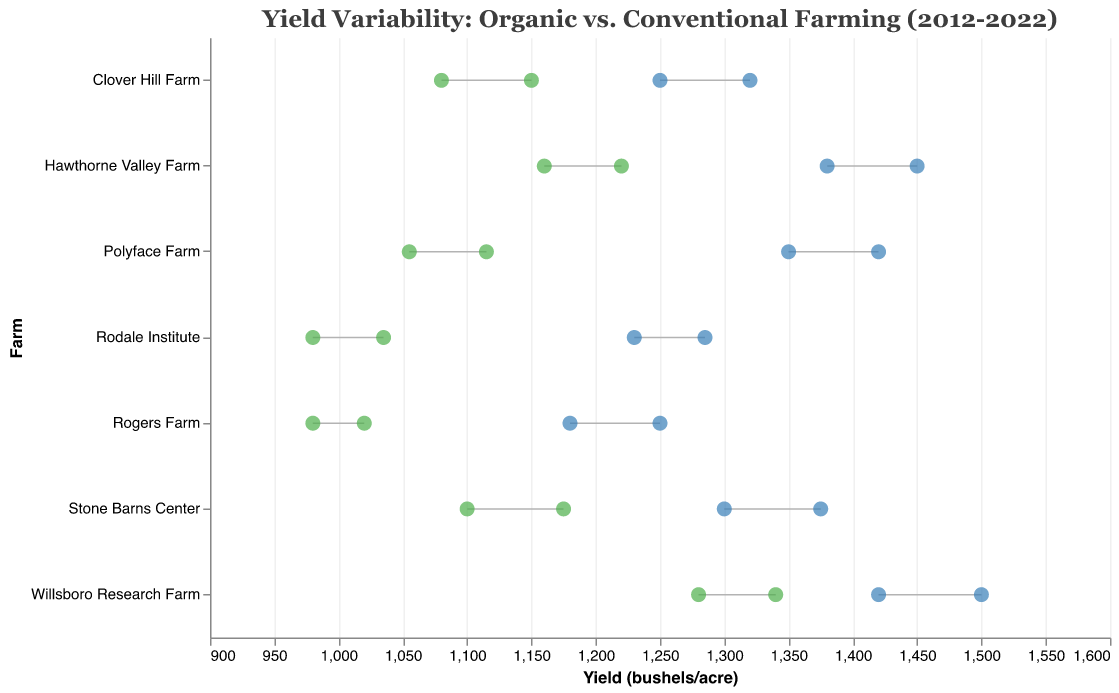what is the title of the plotted figure? The title of the plotted figure is usually positioned at the top center of the chart and provides a summary of what the chart is about. Here, it reads: "Yield Variability: Organic vs. Conventional Farming (2012-2022)."
Answer: Yield Variability: Organic vs. Conventional Farming (2012-2022) What does the color green represent in the figure? In the figure, the color green is used to represent the yield data for organic farming in both 2012 and 2022. The green circles mark the yield values at these two points in time.
Answer: Organic farming Which farm had the highest yield in 2022 under conventional farming methods? To find this, look for the blue circle farthest to the right for the year 2022. That corresponds to the highest yield value in 2022 under conventional farming methods. It is from "Cornell University Ag Extension" with a yield of 1500 bushels/acre.
Answer: Cornell University Ag Extension Which farms increased their yield from 2012 to 2022 under organic farming methods? To answer this, examine the green circles for each farm. If the circle for 2022 is farther to the right than the circle for 2012, the yield increased. "Willsboro Research Farm," "Rogers Farm," "Stone Barns Center," "Polyface Farm," "Rodale Institute," "Hawthorne Valley Farm," and "Clover Hill Farm" all show increased yields.
Answer: Willsboro Research Farm, Rogers Farm, Stone Barns Center, Polyface Farm, Rodale Institute, Hawthorne Valley Farm, Clover Hill Farm What is the average yield in 2022 for organic farming across all farms? Add the 2022 yield values for organic farming for all farms: 1340, 1020, 1175, 1115, 1035, 1220, and 1150, then divide by the number of farms (7). The sum is 8155, and the average yield is 8155 / 7 = 1165 bushels/acre.
Answer: 1165 bushels/acre By how much did the yield increase for "Rodale Institute" from 2012 to 2022 under organic farming methods? Subtract the 2012 yield from the 2022 yield for "Rodale Institute." The yields are 1035 (2022) and 980 (2012). The yield increase is 1035 - 980 = 55 bushels/acre.
Answer: 55 bushels/acre Is there any farm where the yield decreased from 2012 to 2022 under either farming method? Look at the relative positions of the circles for 2012 and 2022 for both organic and conventional methods. All circles for 2022 are to the right of those for 2012, indicating all farms saw increased yields in both methods.
Answer: No Which farming method shows a greater increase in yield from 2012 to 2022 for "Polyface Farm"? Calculate the yield increase for both farming methods. For organic: 1115 (2022) - 1055 (2012) = 60 bushels/acre. For conventional: 1420 (2022) - 1350 (2012) = 70 bushels/acre. Conventional farming shows a greater increase.
Answer: Conventional farming On which farm is the yield difference between organic and conventional methods the greatest in 2022? Calculate the yield difference for 2022 for each farm: subtract the organic yield from the conventional yield in 2022. The greatest difference is for "Cornell University Ag Extension" with 1500 (conventional) - 1340 (organic) = 160 bushels/acre.
Answer: Cornell University Ag Extension For which farm is the yield more consistent between 2012 and 2022 for both farming methods? Look for a farm where the yield change (difference between 2012 and 2022) is minimal for both methods. "Polyface Farm" shows a change of only 60 bushels/acre for organic and 70 bushels/acre for conventional, making it the most consistent.
Answer: Polyface Farm 